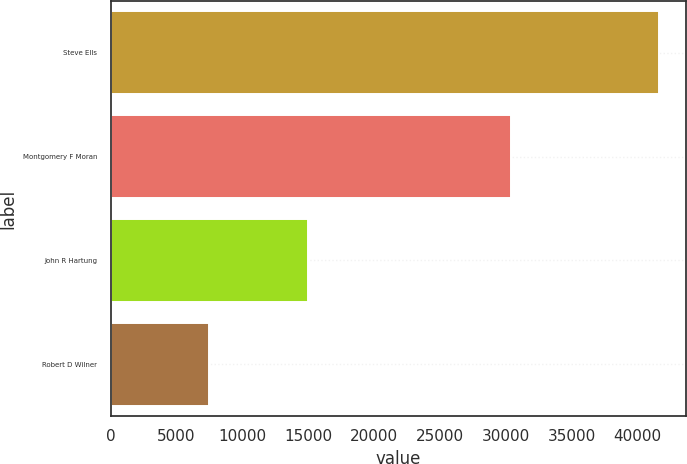<chart> <loc_0><loc_0><loc_500><loc_500><bar_chart><fcel>Steve Ells<fcel>Montgomery F Moran<fcel>John R Hartung<fcel>Robert D Wilner<nl><fcel>41600<fcel>30400<fcel>15000<fcel>7500<nl></chart> 